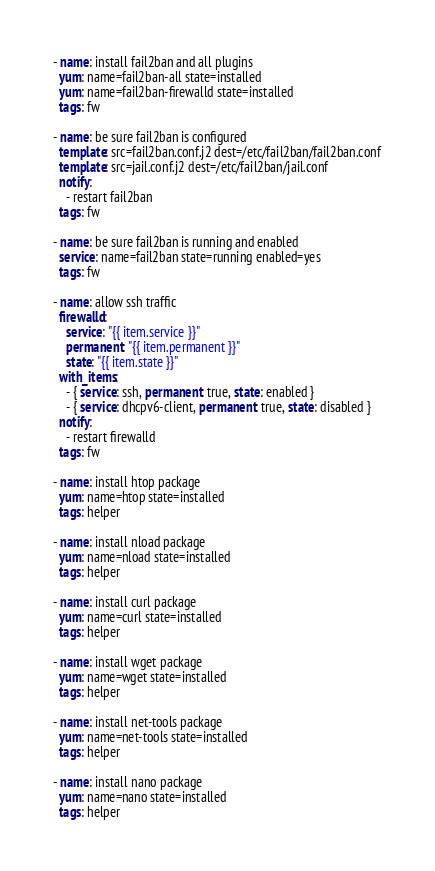<code> <loc_0><loc_0><loc_500><loc_500><_YAML_>- name: install fail2ban and all plugins
  yum: name=fail2ban-all state=installed
  yum: name=fail2ban-firewalld state=installed
  tags: fw

- name: be sure fail2ban is configured
  template: src=fail2ban.conf.j2 dest=/etc/fail2ban/fail2ban.conf
  template: src=jail.conf.j2 dest=/etc/fail2ban/jail.conf
  notify:
    - restart fail2ban
  tags: fw

- name: be sure fail2ban is running and enabled
  service: name=fail2ban state=running enabled=yes
  tags: fw

- name: allow ssh traffic
  firewalld:
    service: "{{ item.service }}"
    permanent: "{{ item.permanent }}"
    state: "{{ item.state }}"
  with_items:
    - { service: ssh, permanent: true, state: enabled }
    - { service: dhcpv6-client, permanent: true, state: disabled }
  notify:
    - restart firewalld
  tags: fw

- name: install htop package
  yum: name=htop state=installed
  tags: helper

- name: install nload package
  yum: name=nload state=installed
  tags: helper

- name: install curl package
  yum: name=curl state=installed
  tags: helper

- name: install wget package
  yum: name=wget state=installed
  tags: helper

- name: install net-tools package
  yum: name=net-tools state=installed
  tags: helper

- name: install nano package
  yum: name=nano state=installed
  tags: helper
</code> 